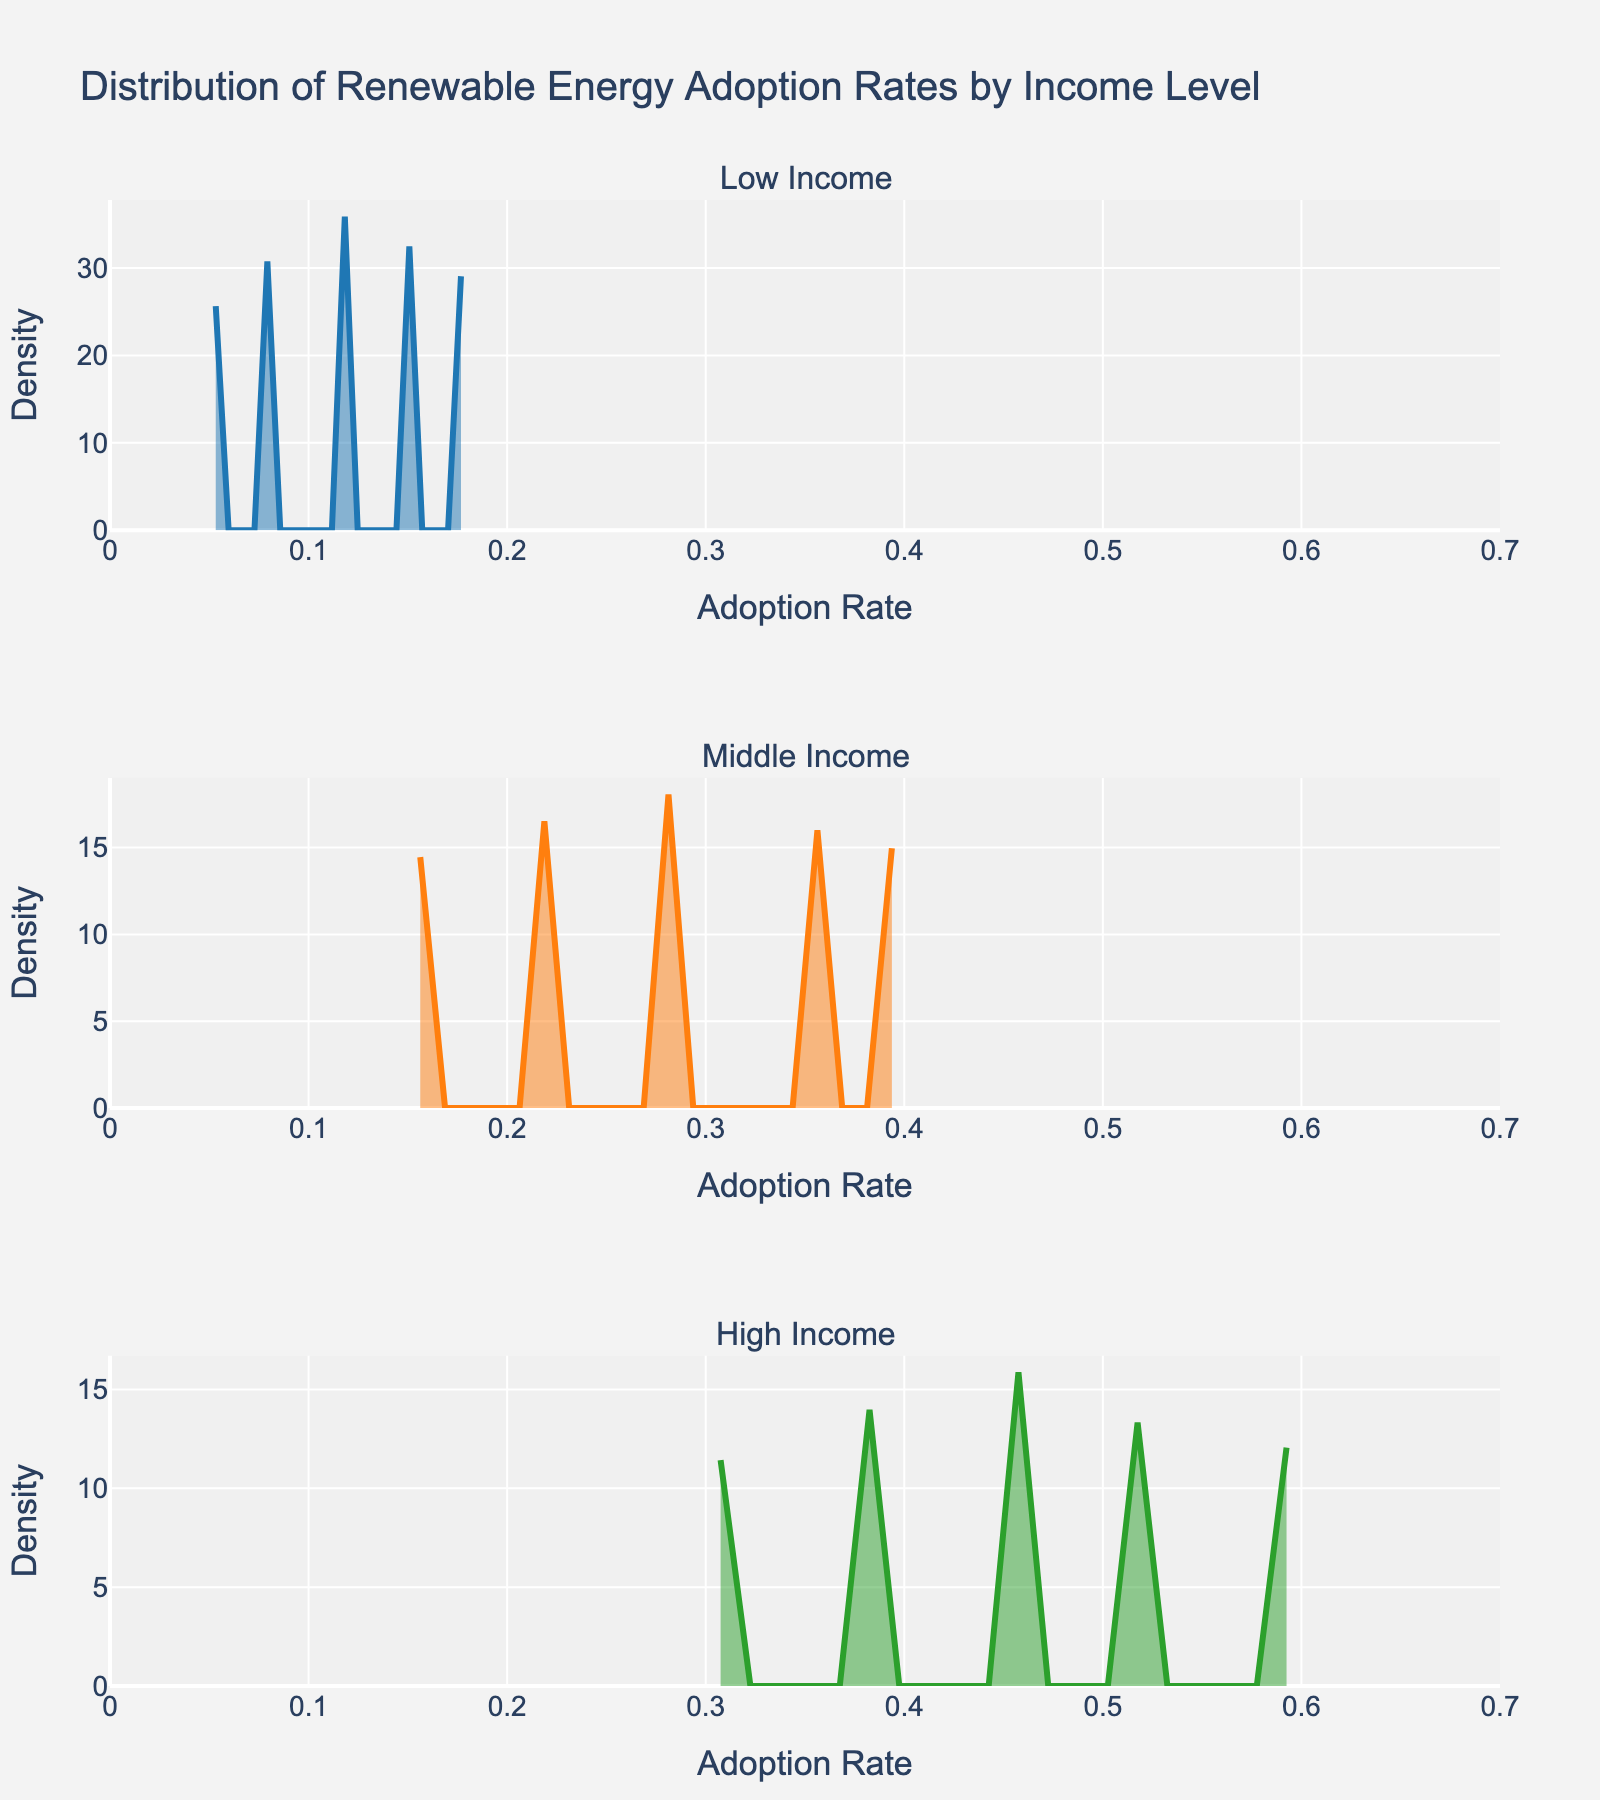What is the title of the plot? The title of the plot is located at the top center of the figure and states the overall description of the plot.
Answer: Distribution of Renewable Energy Adoption Rates by Income Level Which income level has the widest range of adoption rates? By observing the horizontal spread of each subplot, the income level with the widest range of adoption rates will span the largest distance along the x-axis.
Answer: High Income How do the peaks of the density plots for low and high income levels compare? The peaks of the density plots are indicated by the highest points on each curve. Comparing the densities visually will reveal which one has a higher peak.
Answer: The peak of the Low Income plot is higher than the peak of the High Income plot What is the main feature of the y-axis on each subplot? The y-axis on each subplot shows the density of household counts, which is indicated by the label "Density" on the y-axis. This value indicates the concentration of adoption rates.
Answer: Density of household counts Between which adoption rates does the Middle Income density plot show the highest density? By examining the highest points on the Middle Income density plot, we can identify the corresponding range of adoption rates along the x-axis where the density is the highest.
Answer: Between 0.28 and 0.35 Which income level shows a density plot indicating more uniform adoption rates across the range? A more uniform adoption plot would have a flatter curve, indicating that adoption rates are more evenly distributed rather than concentrated at specific values.
Answer: High Income How does the adoption rate at the peak of the Middle Income density plot compare with that of the Low Income density plot? Inspecting both the Middle Income and Low Income density plots, identify the adoption rates corresponding to their peaks and compare these rates.
Answer: The peak of the Middle Income density plot is higher with an adoption rate around 0.28 compared to the Low Income peak which is around 0.12 What can be inferred about renewable energy adoption in high-income households based on the density plot? The density plot for High Income households can be inferred to show that there is a higher concentration of adoption rates above 0.50, compared to lower income levels.
Answer: High-income households tend to have higher adoption rates Which income level's density plot implies the highest concentration of households below a 0.20 adoption rate? Review the density plots for each income level and identify which plot has the highest density values below the 0.20 mark on the x-axis.
Answer: Low Income From visual analysis, which income group has the most varied adoption rates? Analysing the spread and shape of each density plot, identify which income group's adoption rates vary the most across the range.
Answer: High Income 